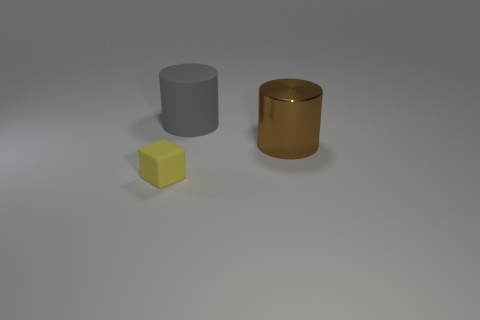Is there anything else that is the same size as the rubber block?
Keep it short and to the point. No. The thing that is made of the same material as the large gray cylinder is what shape?
Your answer should be compact. Cube. There is a brown object that is the same shape as the gray object; what material is it?
Offer a very short reply. Metal. There is a object to the left of the gray matte cylinder; what shape is it?
Your answer should be very brief. Cube. Are there any other things that are the same color as the matte cylinder?
Give a very brief answer. No. Is the number of large gray cylinders in front of the gray rubber object less than the number of big brown metal objects?
Provide a short and direct response. Yes. How many rubber cylinders have the same size as the metallic cylinder?
Provide a short and direct response. 1. There is a big thing that is to the left of the big thing that is in front of the big thing that is left of the brown thing; what shape is it?
Your answer should be very brief. Cylinder. There is a big cylinder right of the large gray cylinder; what color is it?
Your answer should be compact. Brown. What number of things are things on the right side of the yellow cube or small yellow matte objects that are to the left of the big matte cylinder?
Keep it short and to the point. 3. 